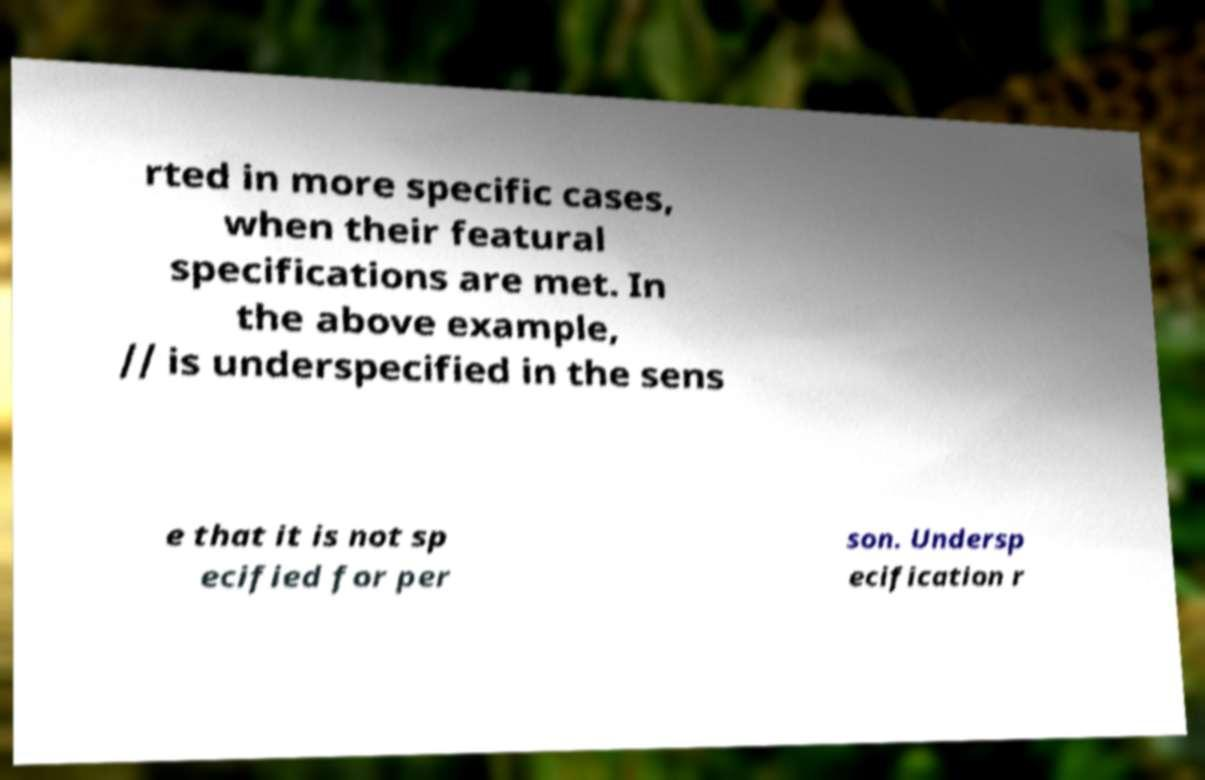For documentation purposes, I need the text within this image transcribed. Could you provide that? rted in more specific cases, when their featural specifications are met. In the above example, // is underspecified in the sens e that it is not sp ecified for per son. Undersp ecification r 